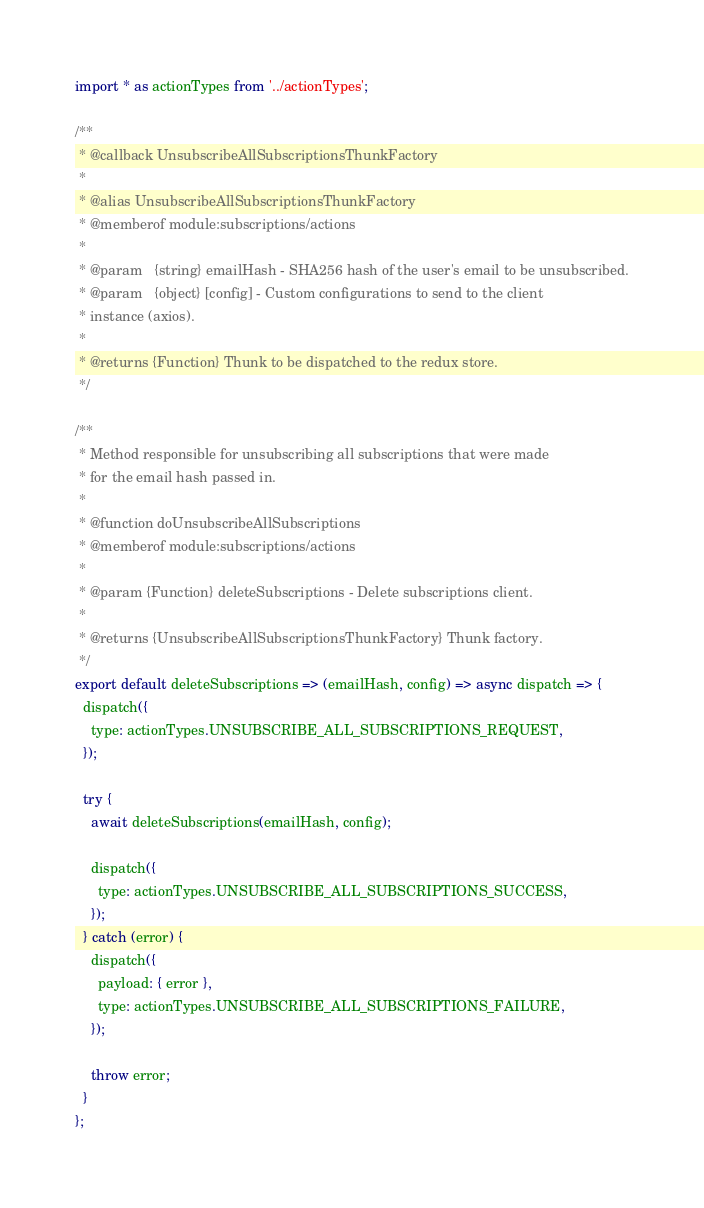Convert code to text. <code><loc_0><loc_0><loc_500><loc_500><_JavaScript_>import * as actionTypes from '../actionTypes';

/**
 * @callback UnsubscribeAllSubscriptionsThunkFactory
 *
 * @alias UnsubscribeAllSubscriptionsThunkFactory
 * @memberof module:subscriptions/actions
 *
 * @param   {string} emailHash - SHA256 hash of the user's email to be unsubscribed.
 * @param   {object} [config] - Custom configurations to send to the client
 * instance (axios).
 *
 * @returns {Function} Thunk to be dispatched to the redux store.
 */

/**
 * Method responsible for unsubscribing all subscriptions that were made
 * for the email hash passed in.
 *
 * @function doUnsubscribeAllSubscriptions
 * @memberof module:subscriptions/actions
 *
 * @param {Function} deleteSubscriptions - Delete subscriptions client.
 *
 * @returns {UnsubscribeAllSubscriptionsThunkFactory} Thunk factory.
 */
export default deleteSubscriptions => (emailHash, config) => async dispatch => {
  dispatch({
    type: actionTypes.UNSUBSCRIBE_ALL_SUBSCRIPTIONS_REQUEST,
  });

  try {
    await deleteSubscriptions(emailHash, config);

    dispatch({
      type: actionTypes.UNSUBSCRIBE_ALL_SUBSCRIPTIONS_SUCCESS,
    });
  } catch (error) {
    dispatch({
      payload: { error },
      type: actionTypes.UNSUBSCRIBE_ALL_SUBSCRIPTIONS_FAILURE,
    });

    throw error;
  }
};
</code> 